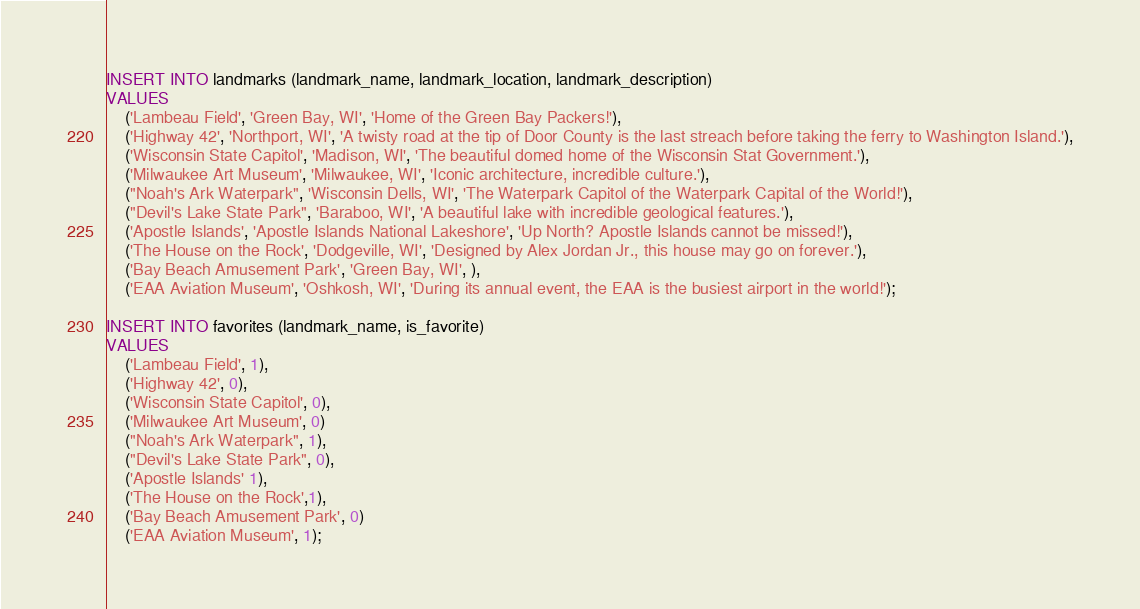Convert code to text. <code><loc_0><loc_0><loc_500><loc_500><_SQL_>INSERT INTO landmarks (landmark_name, landmark_location, landmark_description)
VALUES
    ('Lambeau Field', 'Green Bay, WI', 'Home of the Green Bay Packers!'),
    ('Highway 42', 'Northport, WI', 'A twisty road at the tip of Door County is the last streach before taking the ferry to Washington Island.'),
    ('Wisconsin State Capitol', 'Madison, WI', 'The beautiful domed home of the Wisconsin Stat Government.'),
    ('Milwaukee Art Museum', 'Milwaukee, WI', 'Iconic architecture, incredible culture.'),
    ("Noah's Ark Waterpark", 'Wisconsin Dells, WI', 'The Waterpark Capitol of the Waterpark Capital of the World!'),
    ("Devil's Lake State Park", 'Baraboo, WI', 'A beautiful lake with incredible geological features.'),
    ('Apostle Islands', 'Apostle Islands National Lakeshore', 'Up North? Apostle Islands cannot be missed!'),
    ('The House on the Rock', 'Dodgeville, WI', 'Designed by Alex Jordan Jr., this house may go on forever.'),
    ('Bay Beach Amusement Park', 'Green Bay, WI', ),
    ('EAA Aviation Museum', 'Oshkosh, WI', 'During its annual event, the EAA is the busiest airport in the world!');

INSERT INTO favorites (landmark_name, is_favorite)
VALUES
    ('Lambeau Field', 1),
    ('Highway 42', 0),
    ('Wisconsin State Capitol', 0),
    ('Milwaukee Art Museum', 0)
    ("Noah's Ark Waterpark", 1),
    ("Devil's Lake State Park", 0),
    ('Apostle Islands' 1),
    ('The House on the Rock',1),
    ('Bay Beach Amusement Park', 0)
    ('EAA Aviation Museum', 1);</code> 